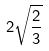<formula> <loc_0><loc_0><loc_500><loc_500>2 \sqrt { \frac { 2 } { 3 } }</formula> 